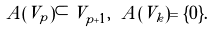<formula> <loc_0><loc_0><loc_500><loc_500>A ( V _ { p } ) \subset V _ { p + 1 } , \ A ( V _ { k } ) = \{ 0 \} .</formula> 